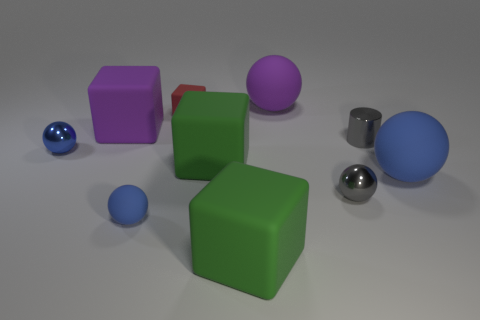What number of objects are purple matte objects left of the red matte object or big purple things that are behind the tiny blue rubber ball?
Your answer should be compact. 2. What shape is the object that is the same color as the small metallic cylinder?
Make the answer very short. Sphere. What shape is the green rubber thing behind the tiny matte ball?
Your response must be concise. Cube. Is the shape of the large blue object in front of the metal cylinder the same as  the tiny red object?
Ensure brevity in your answer.  No. What number of objects are big rubber things that are on the left side of the cylinder or large rubber objects?
Give a very brief answer. 5. There is another shiny thing that is the same shape as the tiny blue shiny thing; what color is it?
Make the answer very short. Gray. Are there any other things of the same color as the tiny cube?
Offer a terse response. No. What is the size of the blue object that is right of the purple sphere?
Your response must be concise. Large. Do the tiny rubber ball and the big ball in front of the red cube have the same color?
Ensure brevity in your answer.  Yes. What number of other things are made of the same material as the red thing?
Offer a very short reply. 6. 